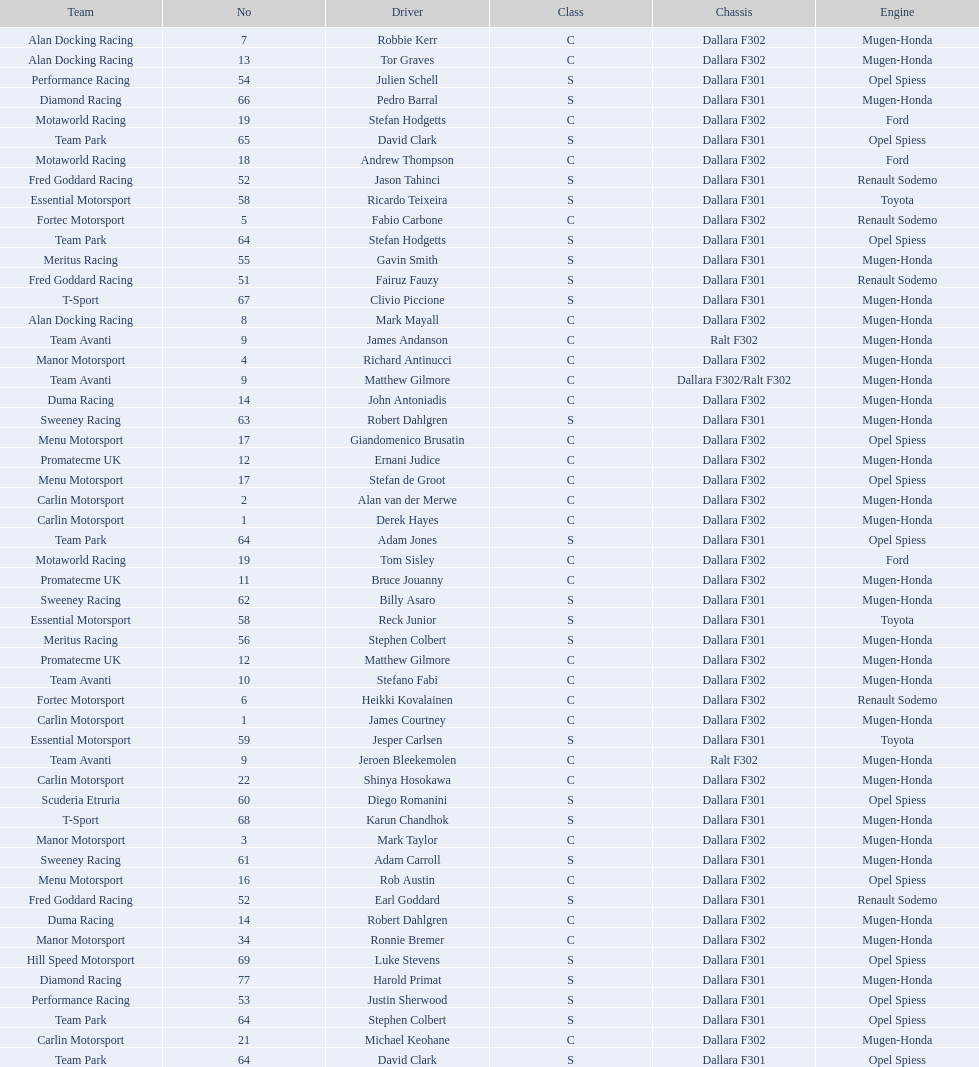The two drivers on t-sport are clivio piccione and what other driver? Karun Chandhok. 